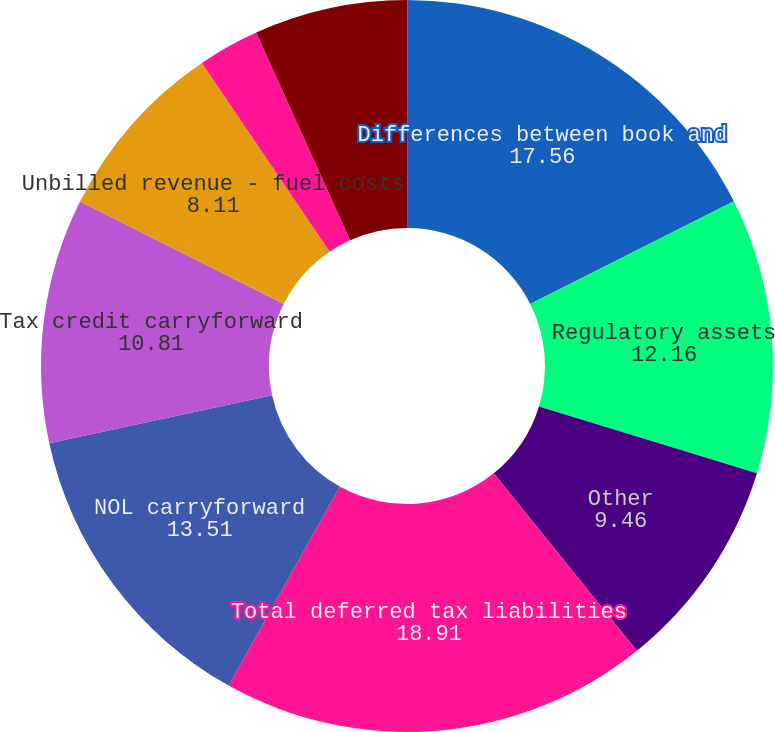Convert chart. <chart><loc_0><loc_0><loc_500><loc_500><pie_chart><fcel>(Thousands of Dollars)<fcel>Differences between book and<fcel>Regulatory assets<fcel>Other<fcel>Total deferred tax liabilities<fcel>NOL carryforward<fcel>Tax credit carryforward<fcel>Unbilled revenue - fuel costs<fcel>Rate refund<fcel>Environmental remediation<nl><fcel>0.01%<fcel>17.56%<fcel>12.16%<fcel>9.46%<fcel>18.91%<fcel>13.51%<fcel>10.81%<fcel>8.11%<fcel>2.71%<fcel>6.76%<nl></chart> 